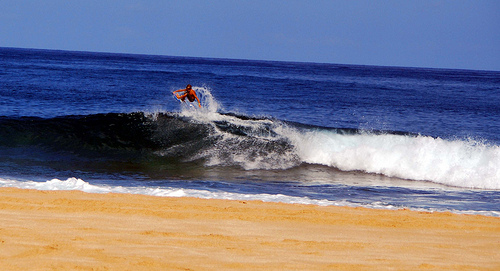Please provide a short description for this region: [0.12, 0.63, 0.2, 0.71]. This particular region unveils a creamy stretch of the tan sandy beach, right before it dips beneath the gentle turquoise wash of the ocean's edge. 